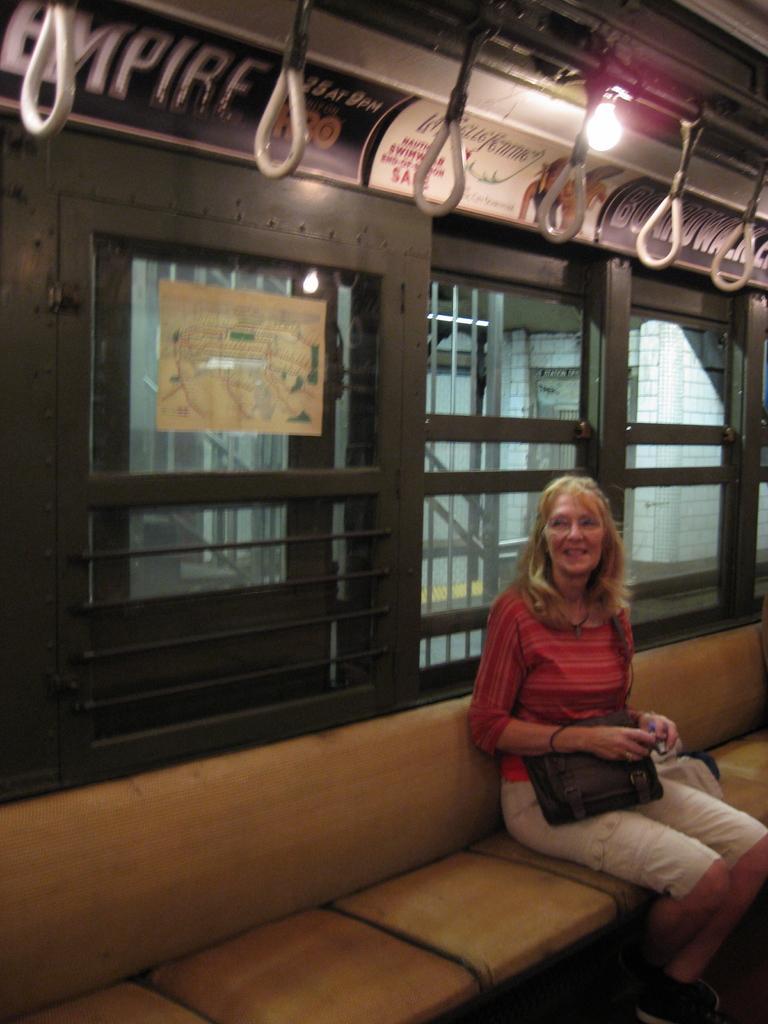Please provide a concise description of this image. In the image there is a lady sitting on seat. And she is holding a bag in her hand. Behind her there are windows with glasses and rods. And also there is a paper attached on the window. Above the window there are poster. At the top of the image there are hanging handles on the rods and also there is a light bulb. 